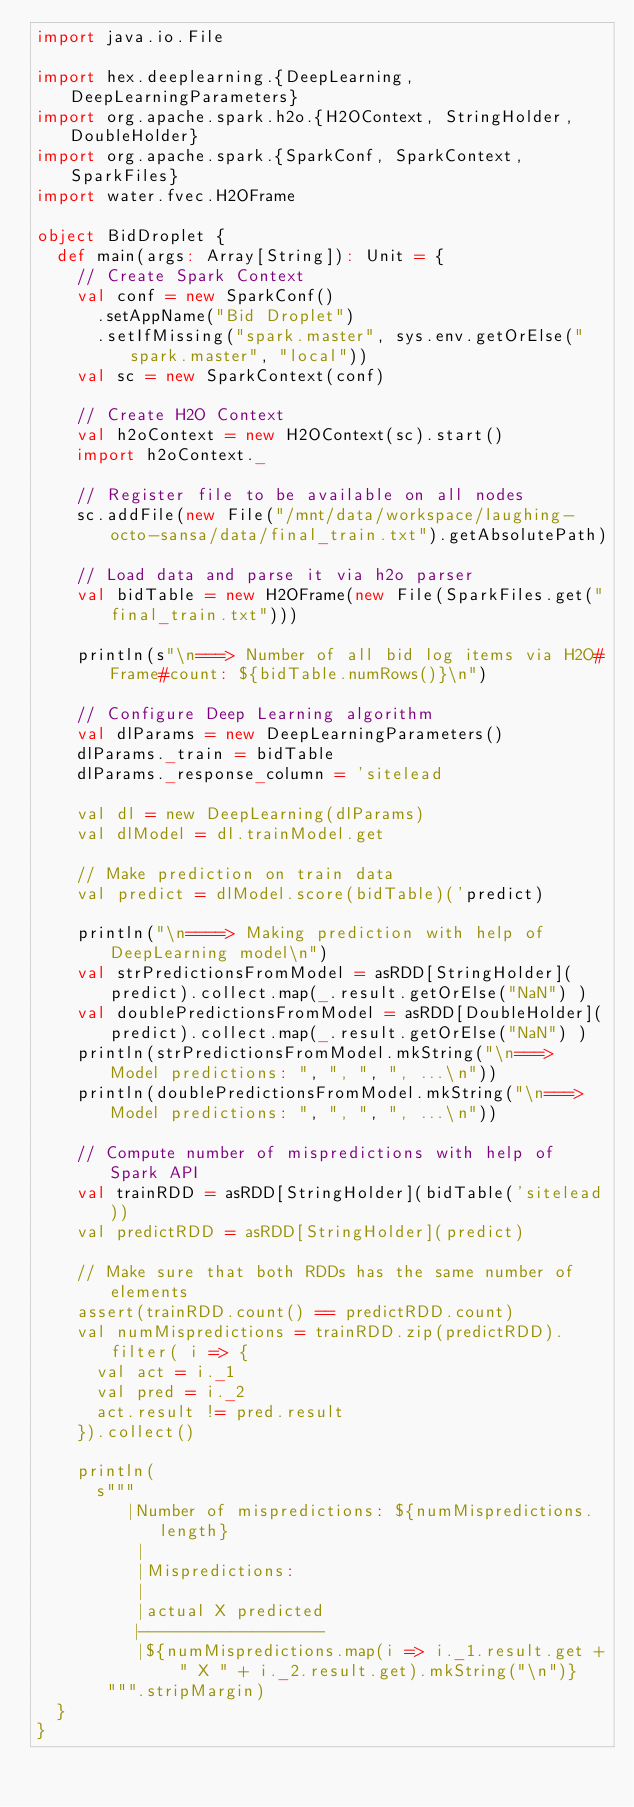<code> <loc_0><loc_0><loc_500><loc_500><_Scala_>import java.io.File

import hex.deeplearning.{DeepLearning, DeepLearningParameters}
import org.apache.spark.h2o.{H2OContext, StringHolder, DoubleHolder}
import org.apache.spark.{SparkConf, SparkContext, SparkFiles}
import water.fvec.H2OFrame

object BidDroplet {
  def main(args: Array[String]): Unit = {
    // Create Spark Context
    val conf = new SparkConf()
      .setAppName("Bid Droplet")
      .setIfMissing("spark.master", sys.env.getOrElse("spark.master", "local"))
    val sc = new SparkContext(conf)

    // Create H2O Context
    val h2oContext = new H2OContext(sc).start()
    import h2oContext._

    // Register file to be available on all nodes
    sc.addFile(new File("/mnt/data/workspace/laughing-octo-sansa/data/final_train.txt").getAbsolutePath)

    // Load data and parse it via h2o parser
    val bidTable = new H2OFrame(new File(SparkFiles.get("final_train.txt")))

    println(s"\n===> Number of all bid log items via H2O#Frame#count: ${bidTable.numRows()}\n")

    // Configure Deep Learning algorithm
    val dlParams = new DeepLearningParameters()
    dlParams._train = bidTable
    dlParams._response_column = 'sitelead

    val dl = new DeepLearning(dlParams)
    val dlModel = dl.trainModel.get

    // Make prediction on train data
    val predict = dlModel.score(bidTable)('predict)

    println("\n====> Making prediction with help of DeepLearning model\n")
    val strPredictionsFromModel = asRDD[StringHolder](predict).collect.map(_.result.getOrElse("NaN") )
    val doublePredictionsFromModel = asRDD[DoubleHolder](predict).collect.map(_.result.getOrElse("NaN") )
    println(strPredictionsFromModel.mkString("\n===> Model predictions: ", ", ", ", ...\n"))
    println(doublePredictionsFromModel.mkString("\n===> Model predictions: ", ", ", ", ...\n"))

    // Compute number of mispredictions with help of Spark API
    val trainRDD = asRDD[StringHolder](bidTable('sitelead))
    val predictRDD = asRDD[StringHolder](predict)

    // Make sure that both RDDs has the same number of elements
    assert(trainRDD.count() == predictRDD.count)
    val numMispredictions = trainRDD.zip(predictRDD).filter( i => {
      val act = i._1
      val pred = i._2
      act.result != pred.result
    }).collect()

    println(
      s"""
         |Number of mispredictions: ${numMispredictions.length}
          |
          |Mispredictions:
          |
          |actual X predicted
          |------------------
          |${numMispredictions.map(i => i._1.result.get + " X " + i._2.result.get).mkString("\n")}
       """.stripMargin)
  }
}
</code> 